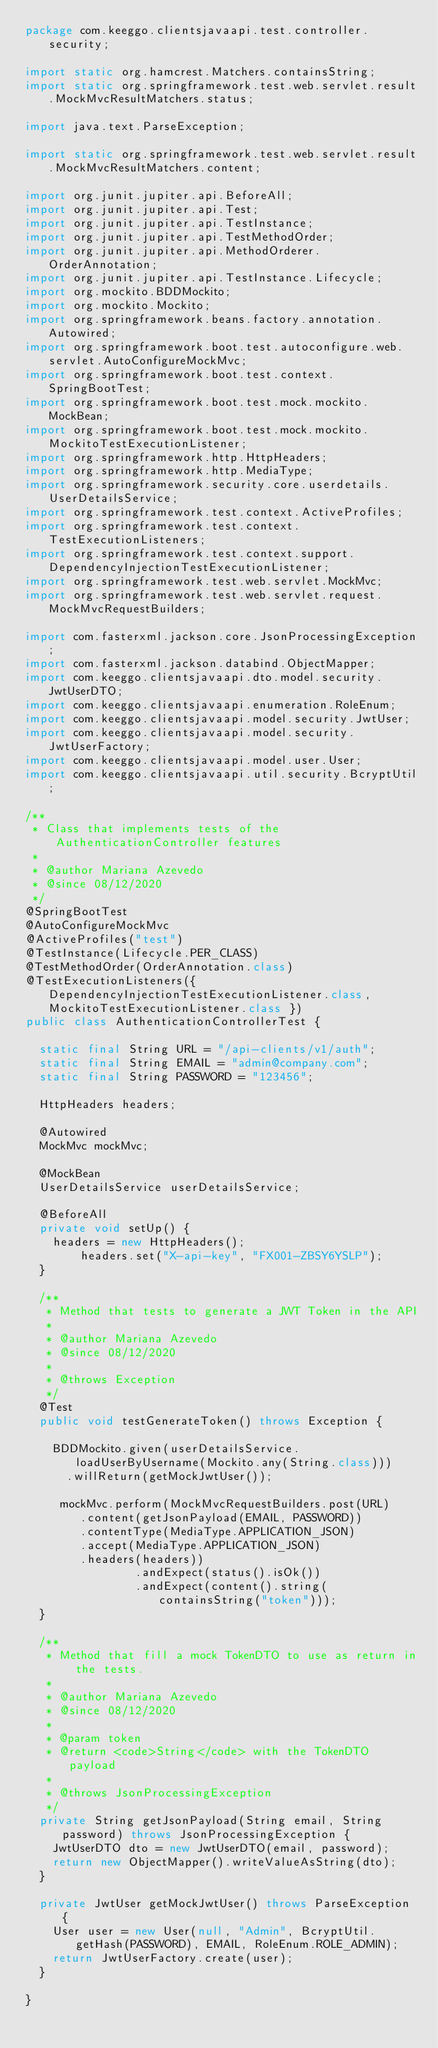Convert code to text. <code><loc_0><loc_0><loc_500><loc_500><_Java_>package com.keeggo.clientsjavaapi.test.controller.security;

import static org.hamcrest.Matchers.containsString;
import static org.springframework.test.web.servlet.result.MockMvcResultMatchers.status;

import java.text.ParseException;

import static org.springframework.test.web.servlet.result.MockMvcResultMatchers.content;

import org.junit.jupiter.api.BeforeAll;
import org.junit.jupiter.api.Test;
import org.junit.jupiter.api.TestInstance;
import org.junit.jupiter.api.TestMethodOrder;
import org.junit.jupiter.api.MethodOrderer.OrderAnnotation;
import org.junit.jupiter.api.TestInstance.Lifecycle;
import org.mockito.BDDMockito;
import org.mockito.Mockito;
import org.springframework.beans.factory.annotation.Autowired;
import org.springframework.boot.test.autoconfigure.web.servlet.AutoConfigureMockMvc;
import org.springframework.boot.test.context.SpringBootTest;
import org.springframework.boot.test.mock.mockito.MockBean;
import org.springframework.boot.test.mock.mockito.MockitoTestExecutionListener;
import org.springframework.http.HttpHeaders;
import org.springframework.http.MediaType;
import org.springframework.security.core.userdetails.UserDetailsService;
import org.springframework.test.context.ActiveProfiles;
import org.springframework.test.context.TestExecutionListeners;
import org.springframework.test.context.support.DependencyInjectionTestExecutionListener;
import org.springframework.test.web.servlet.MockMvc;
import org.springframework.test.web.servlet.request.MockMvcRequestBuilders;

import com.fasterxml.jackson.core.JsonProcessingException;
import com.fasterxml.jackson.databind.ObjectMapper;
import com.keeggo.clientsjavaapi.dto.model.security.JwtUserDTO;
import com.keeggo.clientsjavaapi.enumeration.RoleEnum;
import com.keeggo.clientsjavaapi.model.security.JwtUser;
import com.keeggo.clientsjavaapi.model.security.JwtUserFactory;
import com.keeggo.clientsjavaapi.model.user.User;
import com.keeggo.clientsjavaapi.util.security.BcryptUtil;

/**
 * Class that implements tests of the AuthenticationController features
 * 
 * @author Mariana Azevedo
 * @since 08/12/2020
 */
@SpringBootTest
@AutoConfigureMockMvc
@ActiveProfiles("test")
@TestInstance(Lifecycle.PER_CLASS)
@TestMethodOrder(OrderAnnotation.class)
@TestExecutionListeners({ DependencyInjectionTestExecutionListener.class, MockitoTestExecutionListener.class })
public class AuthenticationControllerTest {

	static final String URL = "/api-clients/v1/auth";
	static final String EMAIL = "admin@company.com";
	static final String PASSWORD = "123456";
	
	HttpHeaders headers;

	@Autowired
	MockMvc mockMvc;
	
	@MockBean
	UserDetailsService userDetailsService;
	
	@BeforeAll
	private void setUp() {
		headers = new HttpHeaders();
        headers.set("X-api-key", "FX001-ZBSY6YSLP");
	}
	
	/**
	 * Method that tests to generate a JWT Token in the API
	 * 
	 * @author Mariana Azevedo
	 * @since 08/12/2020
	 * 
	 * @throws Exception
	 */
	@Test
	public void testGenerateToken() throws Exception {
		
		BDDMockito.given(userDetailsService.loadUserByUsername(Mockito.any(String.class)))
			.willReturn(getMockJwtUser());
		
		 mockMvc.perform(MockMvcRequestBuilders.post(URL)
			 	.content(getJsonPayload(EMAIL, PASSWORD))
			 	.contentType(MediaType.APPLICATION_JSON)
			 	.accept(MediaType.APPLICATION_JSON)
				.headers(headers))
                .andExpect(status().isOk())
                .andExpect(content().string(containsString("token")));
	}
	
	/**
	 * Method that fill a mock TokenDTO to use as return in the tests.
	 * 
	 * @author Mariana Azevedo
	 * @since 08/12/2020
	 * 
	 * @param token
	 * @return <code>String</code> with the TokenDTO payload
	 * 
	 * @throws JsonProcessingException
	 */
	private String getJsonPayload(String email, String password) throws JsonProcessingException {
		JwtUserDTO dto = new JwtUserDTO(email, password);
		return new ObjectMapper().writeValueAsString(dto);
	}
	
	private JwtUser getMockJwtUser() throws ParseException {
		User user = new User(null, "Admin", BcryptUtil.getHash(PASSWORD), EMAIL, RoleEnum.ROLE_ADMIN);
		return JwtUserFactory.create(user);
	}
	
}
</code> 